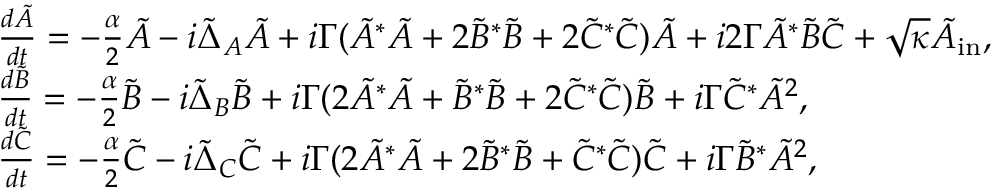<formula> <loc_0><loc_0><loc_500><loc_500>\begin{array} { r l } & { \frac { d \tilde { A } } { d t } = - \frac { \alpha } { 2 } \tilde { A } - i \tilde { \Delta } _ { A } \tilde { A } + i \Gamma ( \tilde { A } ^ { \ast } \tilde { A } + 2 \tilde { B } ^ { \ast } \tilde { B } + 2 \tilde { C } ^ { \ast } \tilde { C } ) \tilde { A } + i 2 \Gamma \tilde { A } ^ { \ast } \tilde { B } \tilde { C } + \sqrt { \kappa } \tilde { A } _ { i n } , } \\ & { \frac { d \tilde { B } } { d t } = - \frac { \alpha } { 2 } \tilde { B } - i \tilde { \Delta } _ { B } \tilde { B } + i \Gamma ( 2 \tilde { A } ^ { \ast } \tilde { A } + \tilde { B } ^ { \ast } \tilde { B } + 2 \tilde { C } ^ { \ast } \tilde { C } ) \tilde { B } + i \Gamma \tilde { C } ^ { \ast } \tilde { A } ^ { 2 } , } \\ & { \frac { d \tilde { C } } { d t } = - \frac { \alpha } { 2 } \tilde { C } - i \tilde { \Delta } _ { C } \tilde { C } + i \Gamma ( 2 \tilde { A } ^ { \ast } \tilde { A } + 2 \tilde { B } ^ { \ast } \tilde { B } + \tilde { C } ^ { \ast } \tilde { C } ) \tilde { C } + i \Gamma \tilde { B } ^ { \ast } \tilde { A } ^ { 2 } , } \end{array}</formula> 